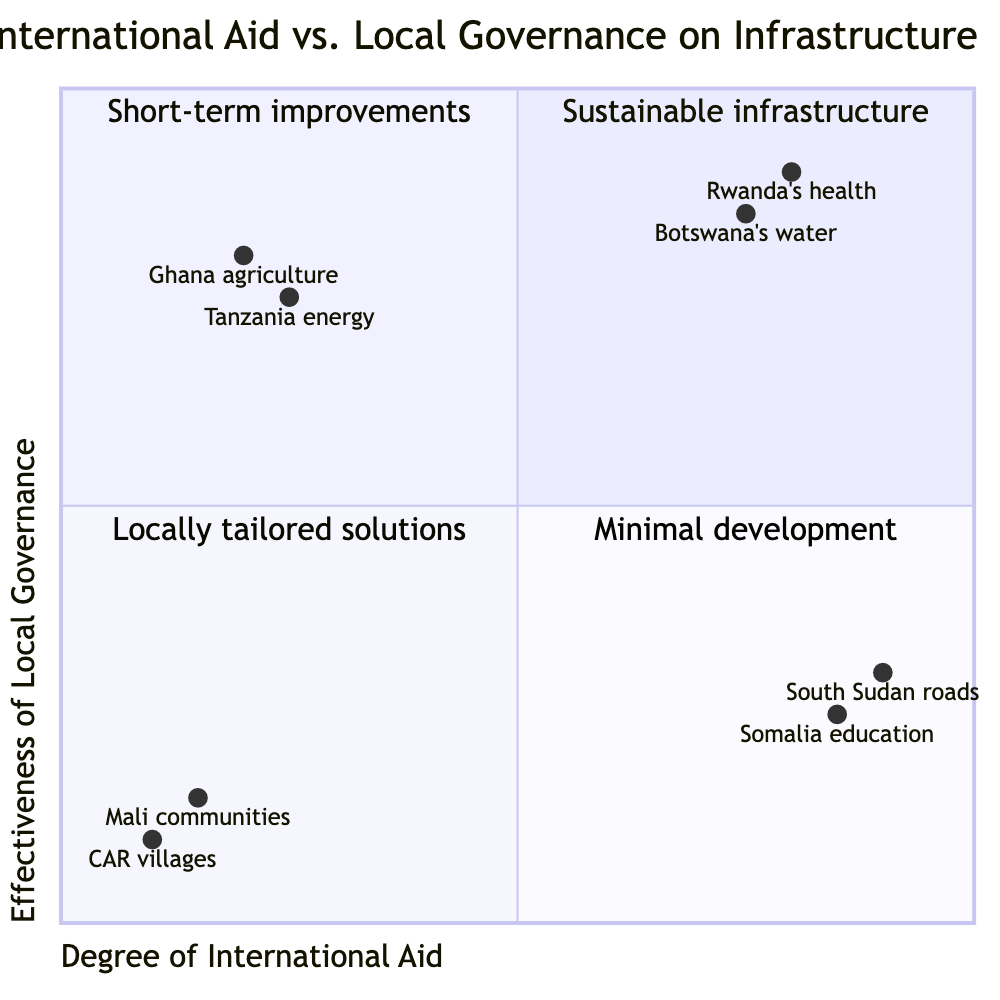What are the examples listed in Q1? Q1, labeled as "High Aid, High Governance," lists “Rwanda's health infrastructure development via Global Fund” and “Botswana's water supply projects with World Bank support” as examples.
Answer: Rwanda's health infrastructure development via Global Fund, Botswana's water supply projects with World Bank support How many quadrants are there in the chart? The diagram has four distinct quadrants, each representing different combinations of international aid and local governance effectiveness.
Answer: Four What is the outcome for Q3? In Q3, which is labeled "Low Aid, High Governance," the outcome listed is "Locally tailored solutions" and "High community ownership."
Answer: Locally tailored solutions, High community ownership In which quadrant does the South Sudan road construction project fall? The South Sudan road construction project is placed in Q2 due to high aid but low governance effectiveness, characterized by "Short-term infrastructure improvements" and "Challenges in maintenance and oversight."
Answer: Q2 What is the effectiveness of local governance for the example of Ghana's agriculture initiatives? The effectiveness of local governance for Ghana's agriculture initiatives is measured at 0.8, indicating high governance effectiveness despite low international aid.
Answer: 0.8 Which quadrant has the least infrastructure development? Q4, labeled as "Low Aid, Low Governance," is noted for having "Minimal infrastructure development" and "Limited public services," representing the quadrant with the least development.
Answer: Q4 What is the degree of international aid for the Tanzania energy project? The degree of international aid for the community-led clean energy projects in Tanzania is recorded at 0.25, indicating low levels of international funding.
Answer: 0.25 How does the effectiveness of local governance in Mali compare to the Central African Republic? Both the Mali communities and Central African Republic villages have low governance effectiveness, with Mali at 0.15 and CAR at 0.1, positioning both in Q4 for low aid and governance.
Answer: Similar (both low) How many examples fall under Q2? There are two examples listed under Q2: “Aid for road construction in South Sudan” and “Educational grants in Somalia,” indicating that this quadrant has two illustrative cases.
Answer: Two 